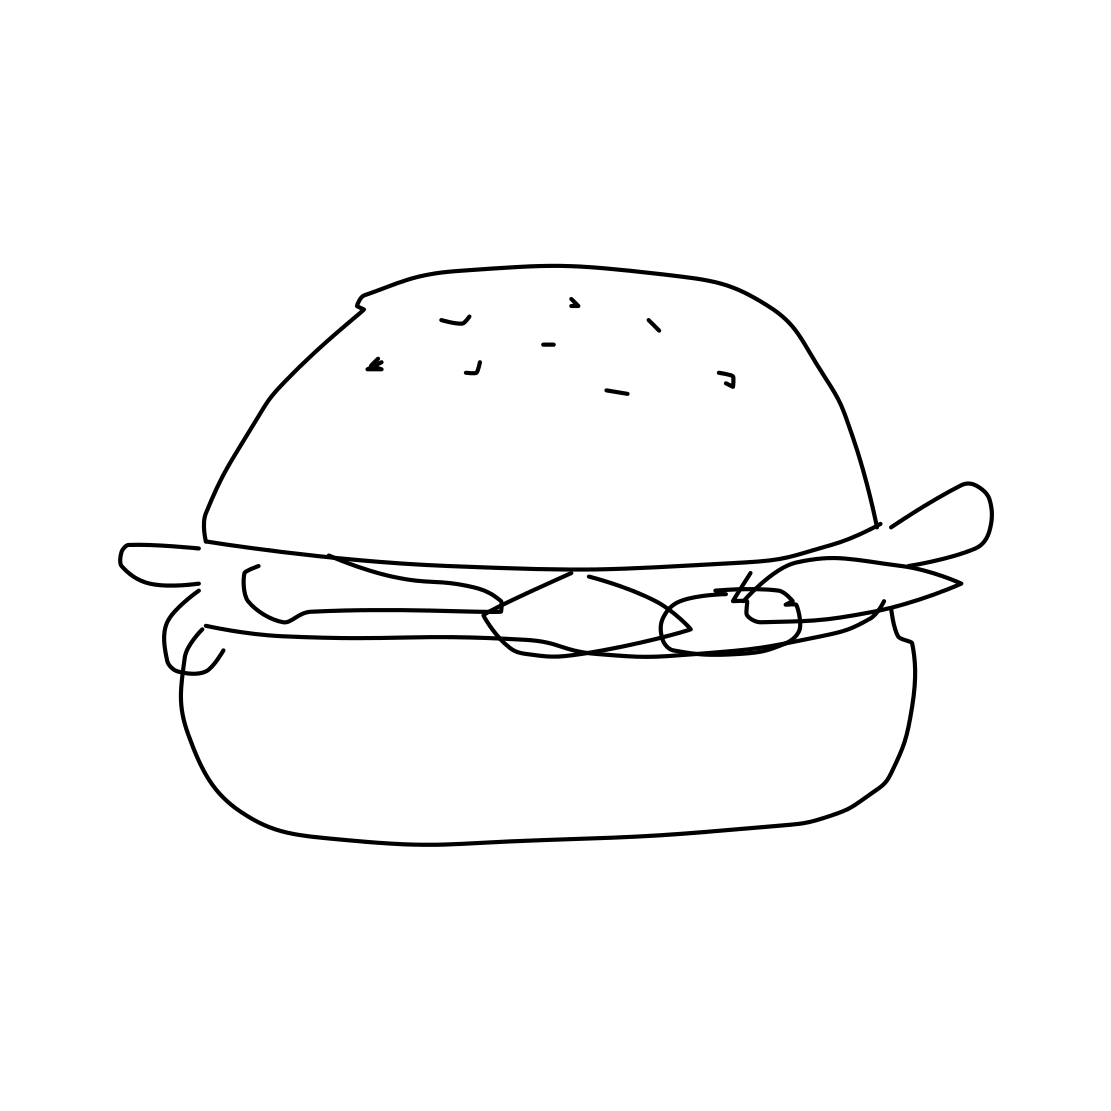In the scene, is a hamburger in it? Yes, the image clearly depicts a hamburger, complete with a top bun sprinkled with seeds, layers of what appears to be meat and vegetables, and a bottom bun. The simple line drawing style effectively captures the essence of a classic hamburger. 